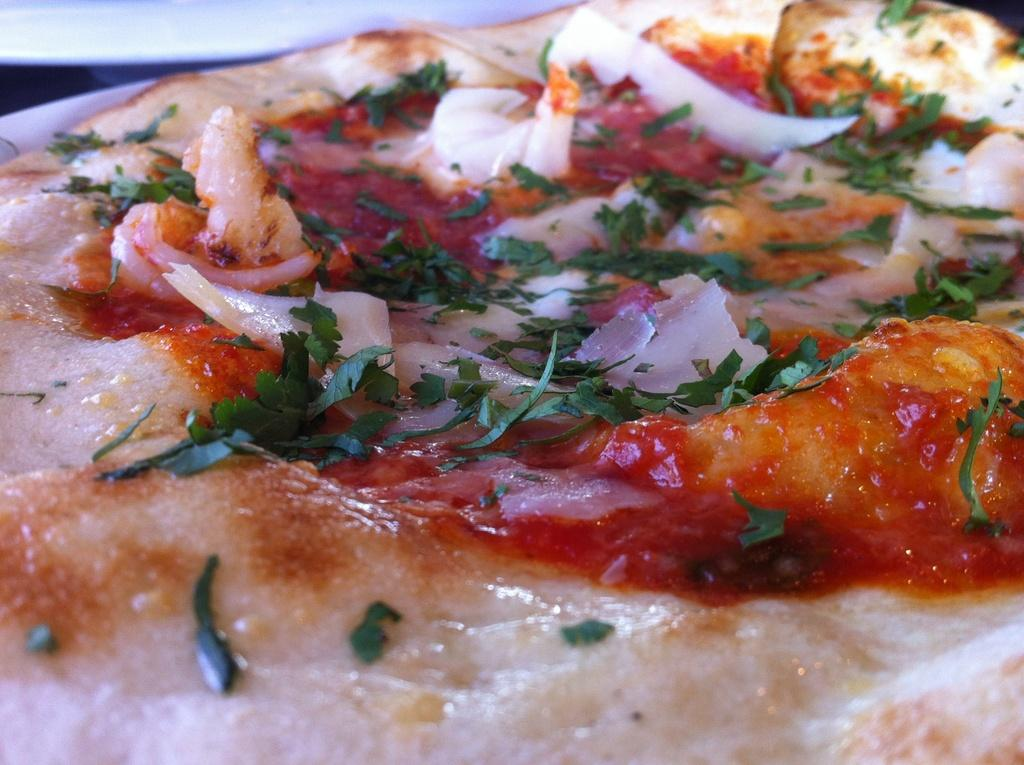What type of food is visible on a plate in the image? There is a pizza on a plate in the image. What type of tax is being discussed in the image? There is no mention of tax in the image; it features a pizza on a plate. What type of work is being performed in the image? There is no work being performed in the image; it features a pizza on a plate. 